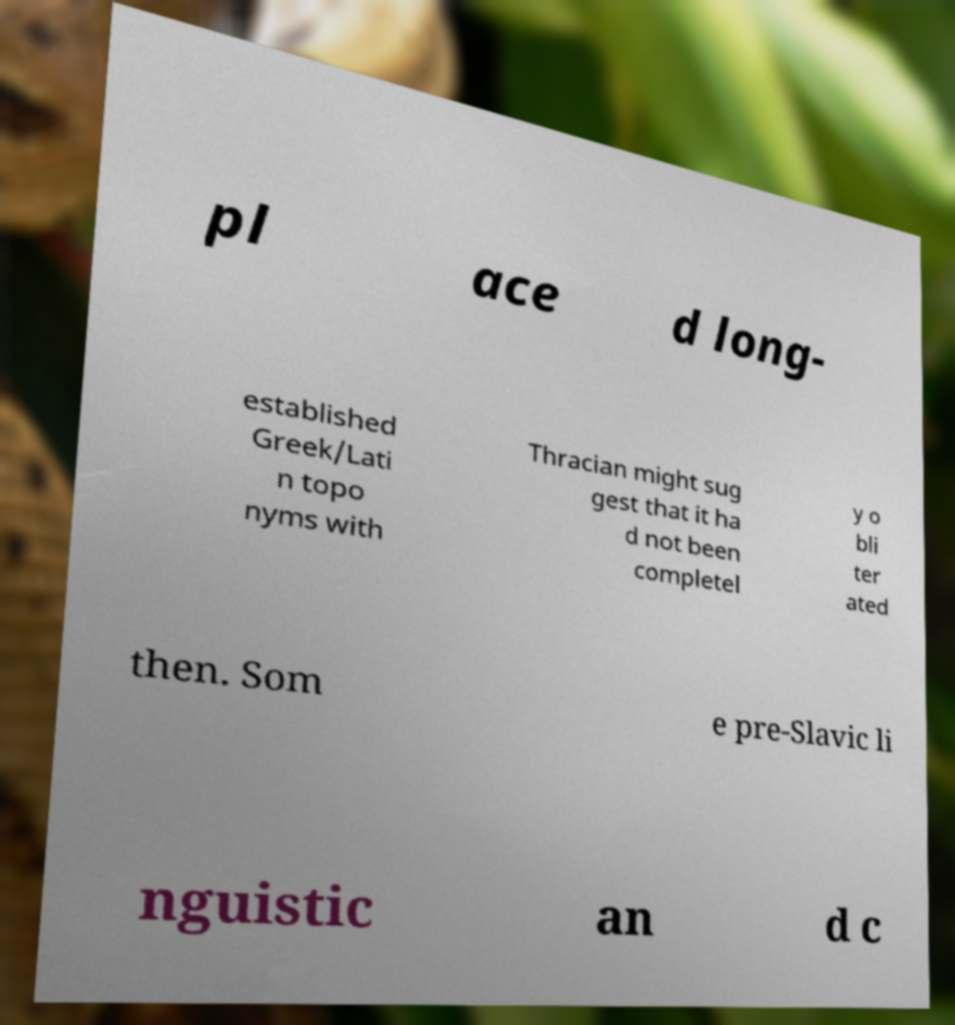Can you accurately transcribe the text from the provided image for me? pl ace d long- established Greek/Lati n topo nyms with Thracian might sug gest that it ha d not been completel y o bli ter ated then. Som e pre-Slavic li nguistic an d c 